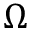Convert formula to latex. <formula><loc_0><loc_0><loc_500><loc_500>\Omega</formula> 